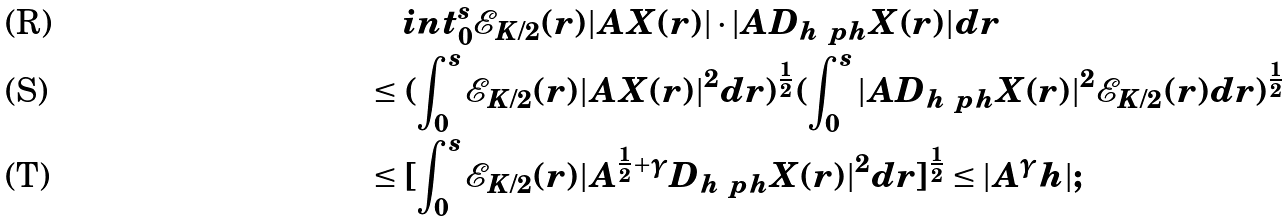Convert formula to latex. <formula><loc_0><loc_0><loc_500><loc_500>& \quad i n t _ { 0 } ^ { s } \mathcal { E } _ { K / 2 } ( r ) | A X ( r ) | \cdot | A D _ { h ^ { \ } p h } X ( r ) | d r \\ & \leq ( \int _ { 0 } ^ { s } \mathcal { E } _ { K / 2 } ( r ) | A X ( r ) | ^ { 2 } d r ) ^ { \frac { 1 } { 2 } } ( \int _ { 0 } ^ { s } | A D _ { h ^ { \ } p h } X ( r ) | ^ { 2 } \mathcal { E } _ { K / 2 } ( r ) d r ) ^ { \frac { 1 } { 2 } } \\ & \leq [ \int _ { 0 } ^ { s } \mathcal { E } _ { K / 2 } ( r ) | A ^ { \frac { 1 } { 2 } + \gamma } D _ { h ^ { \ } p h } X ( r ) | ^ { 2 } d r ] ^ { \frac { 1 } { 2 } } \leq | A ^ { \gamma } h | ;</formula> 